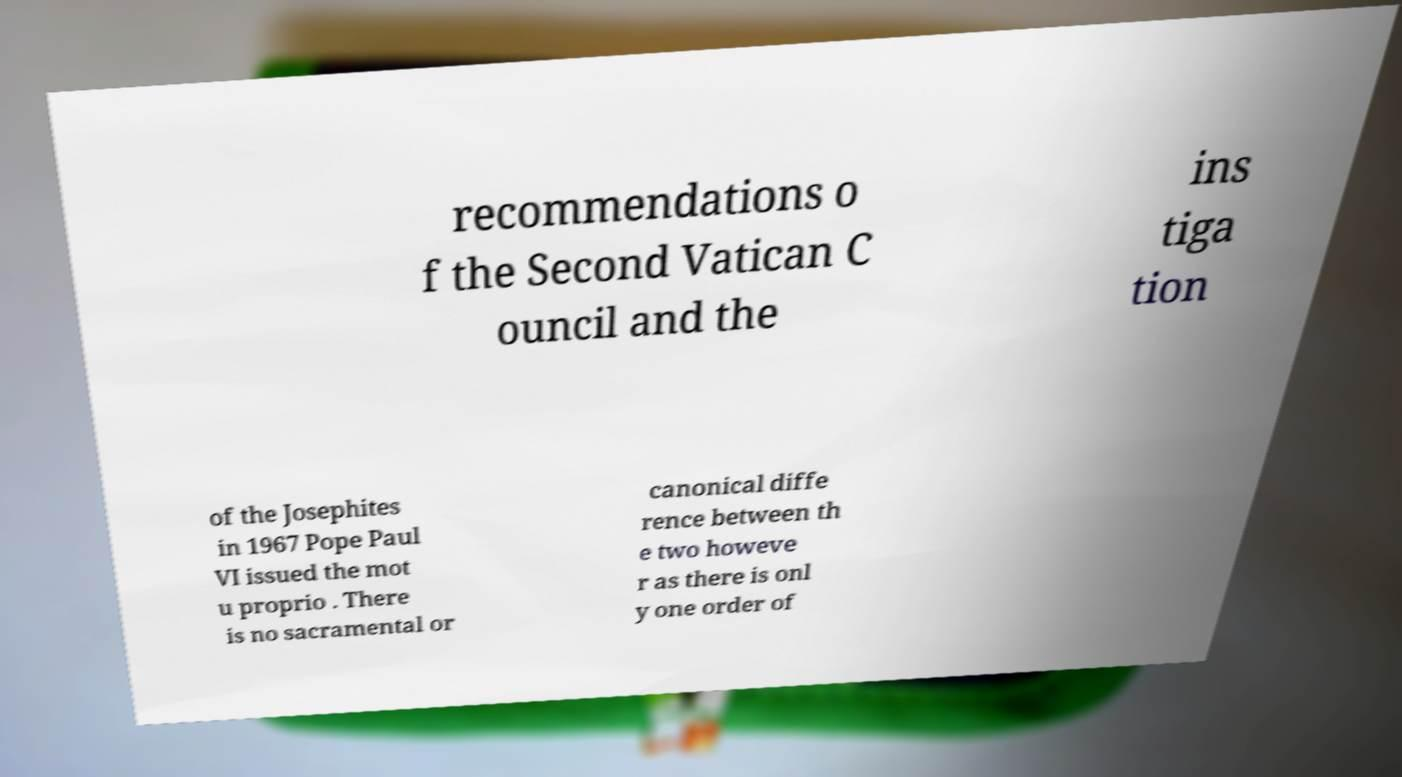Could you extract and type out the text from this image? recommendations o f the Second Vatican C ouncil and the ins tiga tion of the Josephites in 1967 Pope Paul VI issued the mot u proprio . There is no sacramental or canonical diffe rence between th e two howeve r as there is onl y one order of 